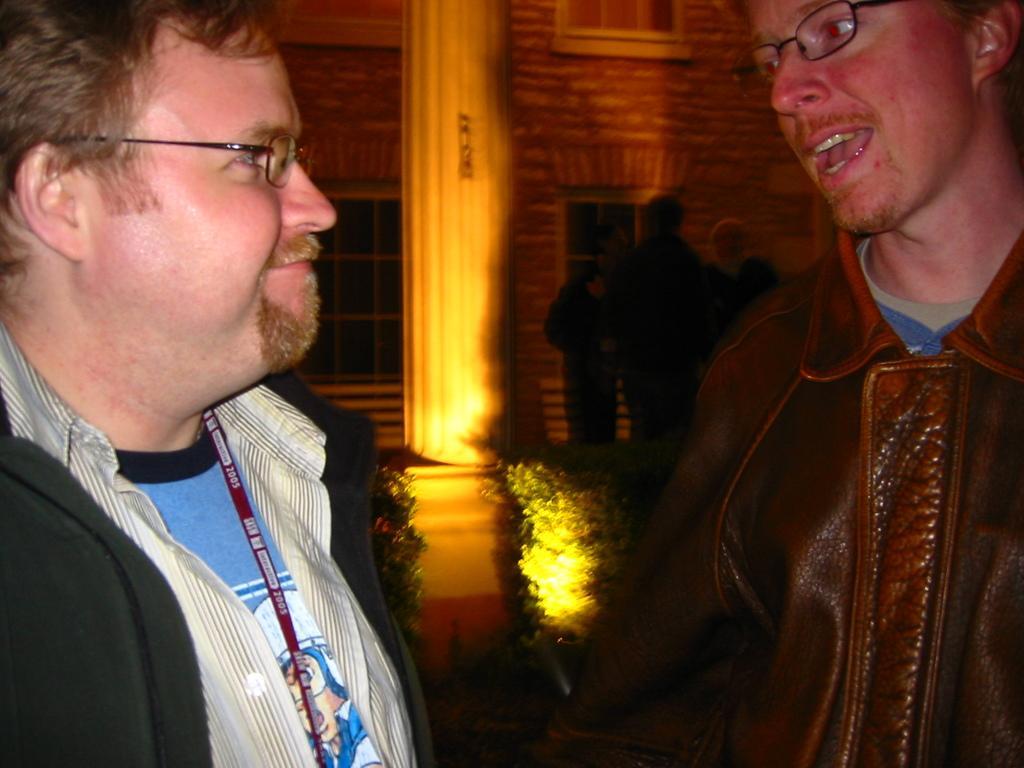How would you summarize this image in a sentence or two? In the picture we can see a two men are facing to each other and talking and smiling and they are wearing jackets and one man is wearing a tag and behind them we can see a pillar and some plants near it and a light focus to the pillar and behind it we can see some people are standing and talking near the building wall with a windows to it. 